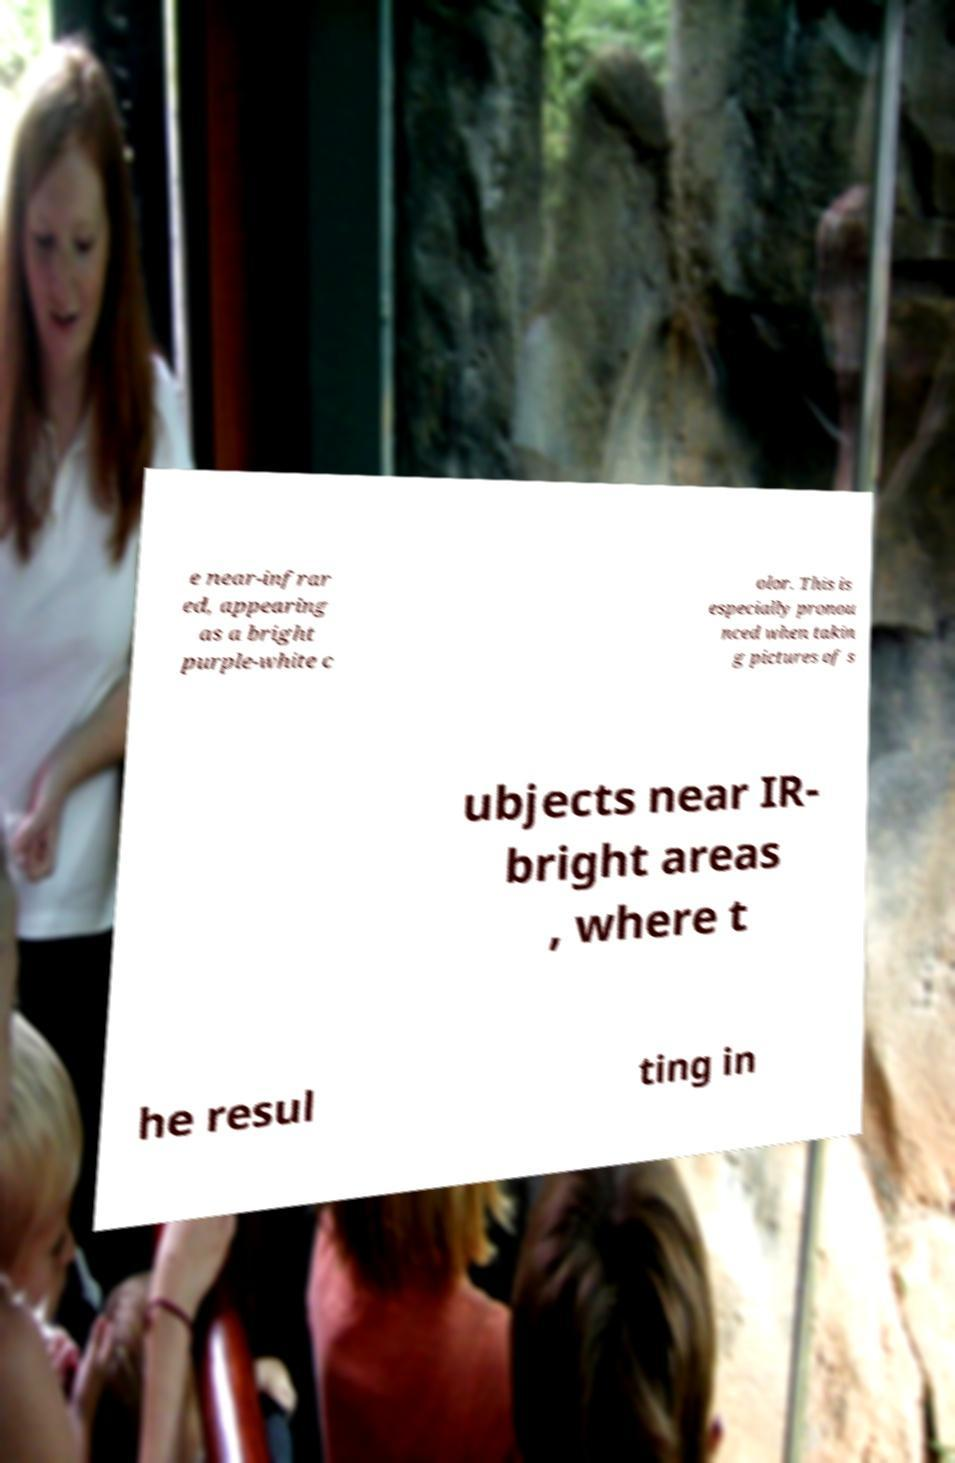For documentation purposes, I need the text within this image transcribed. Could you provide that? e near-infrar ed, appearing as a bright purple-white c olor. This is especially pronou nced when takin g pictures of s ubjects near IR- bright areas , where t he resul ting in 